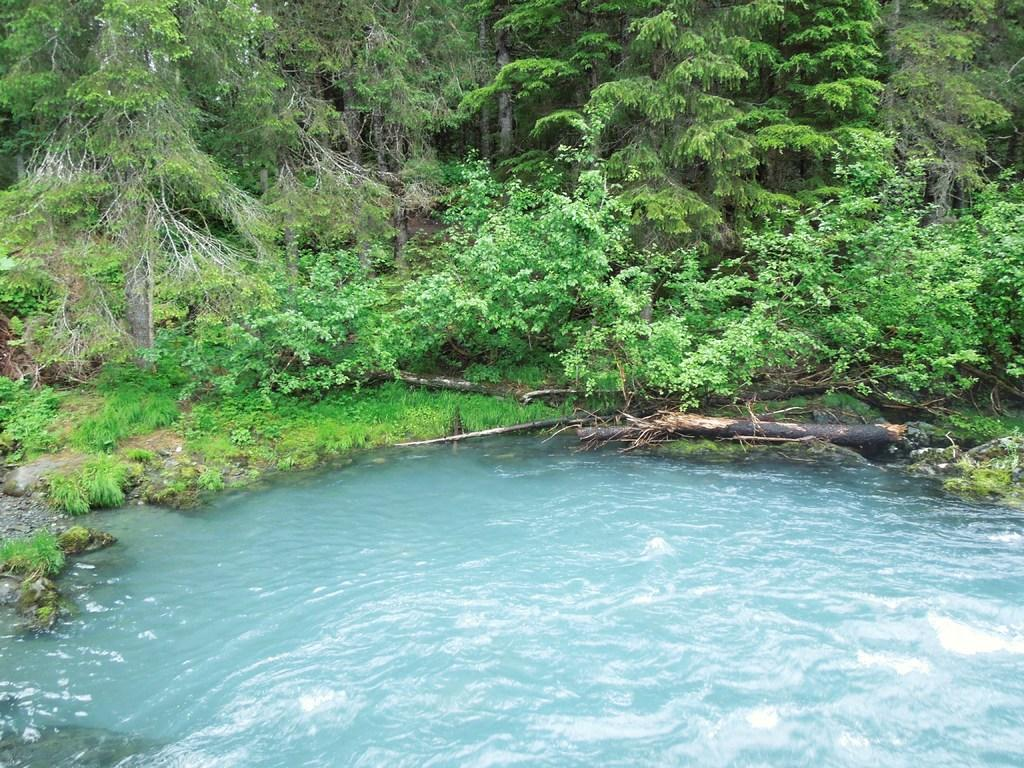What is the primary element visible in the image? There is water in the image. What can be seen beside the water? There is land beside the water. What type of vegetation is present on the land? There are plants and trees on the land. What material are the trunks made of on the land? The wooden trunks on the land are made of wood. What type of birthday celebration is taking place near the water in the image? There is no indication of a birthday celebration in the image. 